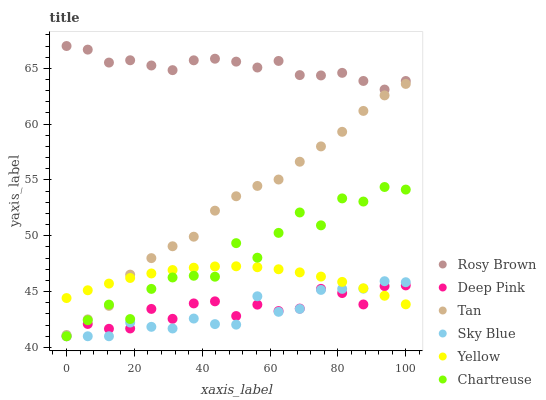Does Sky Blue have the minimum area under the curve?
Answer yes or no. Yes. Does Rosy Brown have the maximum area under the curve?
Answer yes or no. Yes. Does Yellow have the minimum area under the curve?
Answer yes or no. No. Does Yellow have the maximum area under the curve?
Answer yes or no. No. Is Yellow the smoothest?
Answer yes or no. Yes. Is Chartreuse the roughest?
Answer yes or no. Yes. Is Rosy Brown the smoothest?
Answer yes or no. No. Is Rosy Brown the roughest?
Answer yes or no. No. Does Deep Pink have the lowest value?
Answer yes or no. Yes. Does Yellow have the lowest value?
Answer yes or no. No. Does Rosy Brown have the highest value?
Answer yes or no. Yes. Does Yellow have the highest value?
Answer yes or no. No. Is Tan less than Rosy Brown?
Answer yes or no. Yes. Is Rosy Brown greater than Chartreuse?
Answer yes or no. Yes. Does Yellow intersect Deep Pink?
Answer yes or no. Yes. Is Yellow less than Deep Pink?
Answer yes or no. No. Is Yellow greater than Deep Pink?
Answer yes or no. No. Does Tan intersect Rosy Brown?
Answer yes or no. No. 